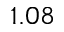Convert formula to latex. <formula><loc_0><loc_0><loc_500><loc_500>1 . 0 8</formula> 